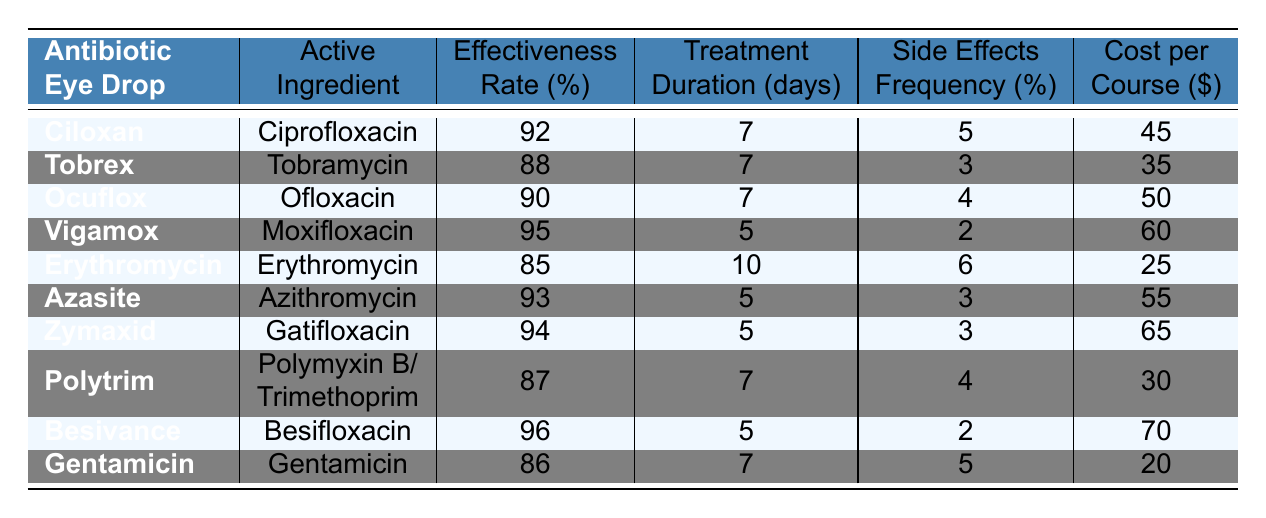What is the effectiveness rate of Besivance? Besivance has an effectiveness rate of 96%, as listed in the table under the "Effectiveness Rate (%)" column.
Answer: 96% Which antibiotic eye drop has the lowest effectiveness rate? The antibiotic eye drop with the lowest effectiveness rate is Erythromycin, with an effectiveness rate of 85%.
Answer: Erythromycin What is the average treatment duration for all the eye drops listed? The treatment durations for the drops are 7, 7, 7, 5, 10, 5, 5, 7, 5, 7 days. Summing them up gives 7 + 7 + 7 + 5 + 10 + 5 + 5 + 7 + 5 + 7 = 66 days. There are 10 drops, so the average treatment duration is 66/10 = 6.6 days.
Answer: 6.6 days Is the side effects frequency of Tobrex lower than that of Erythromycin? Tobrex has a side effects frequency of 3%, while Erythromycin has 6%. Since 3% is less than 6%, the statement is true.
Answer: Yes How much does it cost to complete a course of Zymaxid compared to Gentamicin? Zymaxid costs $65, while Gentamicin costs $20. The difference is calculated as 65 - 20 = $45, so Zymaxid is $45 more expensive than Gentamicin.
Answer: $45 Which eye drop has the highest cost per course and how much is it? Besivance has the highest cost per course at $70, as observed in the "Cost per Course ($)" column.
Answer: $70 What is the combined effectiveness rate of the top three most effective eye drops? The top three most effective eye drops are Vigamox (95%), Besivance (96%), and Zymaxid (94%). Summing these rates gives 95 + 96 + 94 = 285%. The combined effectiveness rate of these three drops is thus 285%.
Answer: 285% Are there any eye drops that have a treatment duration of 10 days? Only Erythromycin has a treatment duration of 10 days, as identified under the "Treatment Duration (days)" column. Therefore, the answer is yes.
Answer: Yes What is the frequency of side effects for the eye drop with the highest effectiveness rate? Besivance has the highest effectiveness rate of 96% and has a side effects frequency of 2%, as stated in the table.
Answer: 2% If we compare the effectiveness rates, how much more effective is Vigamox compared to Erythromycin? Vigamox has an effectiveness rate of 95% and Erythromycin has 85%. The difference is 95 - 85 = 10%. This means Vigamox is 10% more effective than Erythromycin.
Answer: 10% 